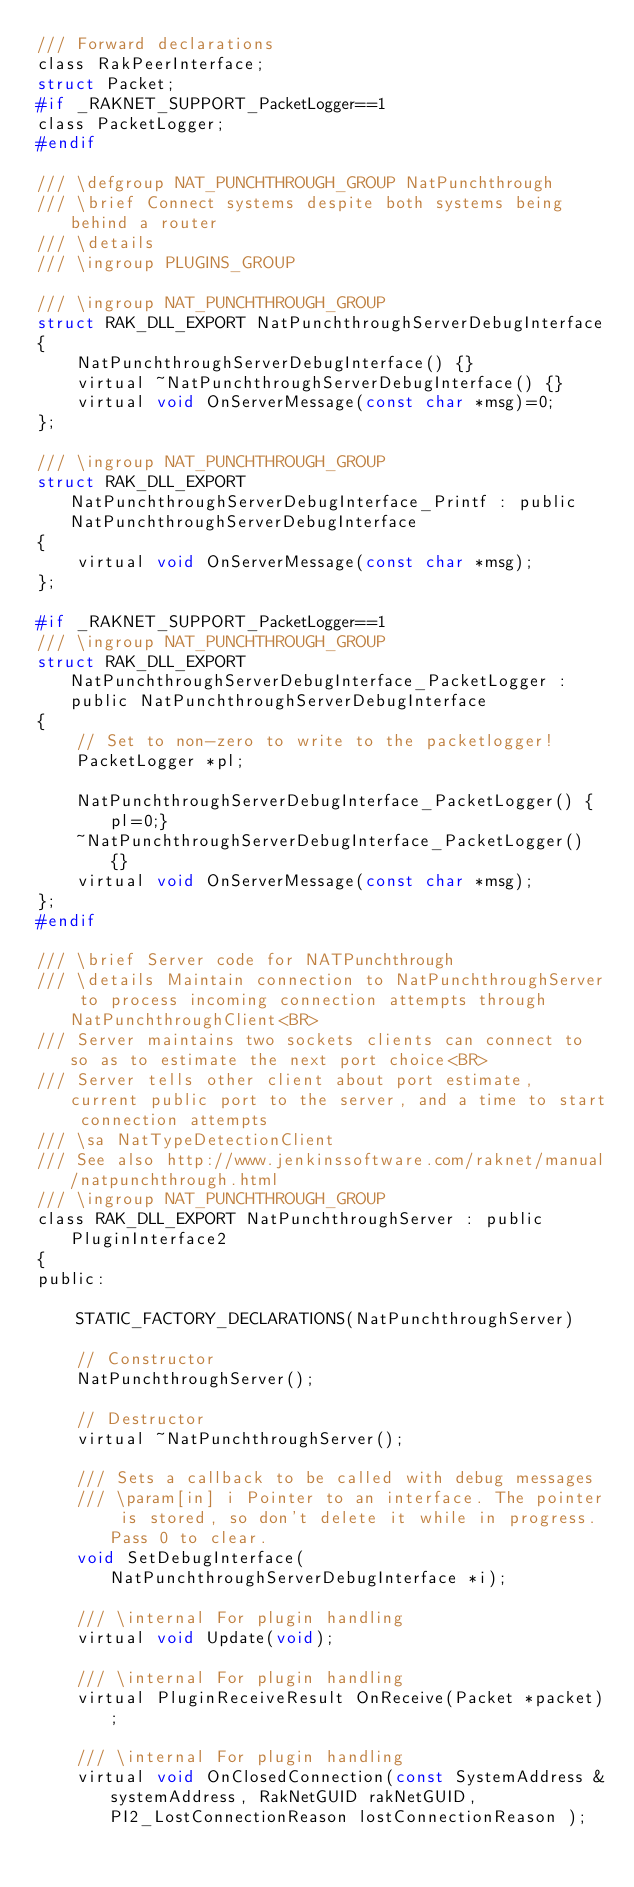Convert code to text. <code><loc_0><loc_0><loc_500><loc_500><_C_>/// Forward declarations
class RakPeerInterface;
struct Packet;
#if _RAKNET_SUPPORT_PacketLogger==1
class PacketLogger;
#endif

/// \defgroup NAT_PUNCHTHROUGH_GROUP NatPunchthrough
/// \brief Connect systems despite both systems being behind a router
/// \details
/// \ingroup PLUGINS_GROUP

/// \ingroup NAT_PUNCHTHROUGH_GROUP
struct RAK_DLL_EXPORT NatPunchthroughServerDebugInterface
{
	NatPunchthroughServerDebugInterface() {}
	virtual ~NatPunchthroughServerDebugInterface() {}
	virtual void OnServerMessage(const char *msg)=0;
};

/// \ingroup NAT_PUNCHTHROUGH_GROUP
struct RAK_DLL_EXPORT NatPunchthroughServerDebugInterface_Printf : public NatPunchthroughServerDebugInterface
{
	virtual void OnServerMessage(const char *msg);
};

#if _RAKNET_SUPPORT_PacketLogger==1
/// \ingroup NAT_PUNCHTHROUGH_GROUP
struct RAK_DLL_EXPORT NatPunchthroughServerDebugInterface_PacketLogger : public NatPunchthroughServerDebugInterface
{
	// Set to non-zero to write to the packetlogger!
	PacketLogger *pl;

	NatPunchthroughServerDebugInterface_PacketLogger() {pl=0;}
	~NatPunchthroughServerDebugInterface_PacketLogger() {}
	virtual void OnServerMessage(const char *msg);
};
#endif

/// \brief Server code for NATPunchthrough
/// \details Maintain connection to NatPunchthroughServer to process incoming connection attempts through NatPunchthroughClient<BR>
/// Server maintains two sockets clients can connect to so as to estimate the next port choice<BR>
/// Server tells other client about port estimate, current public port to the server, and a time to start connection attempts
/// \sa NatTypeDetectionClient
/// See also http://www.jenkinssoftware.com/raknet/manual/natpunchthrough.html
/// \ingroup NAT_PUNCHTHROUGH_GROUP
class RAK_DLL_EXPORT NatPunchthroughServer : public PluginInterface2
{
public:

	STATIC_FACTORY_DECLARATIONS(NatPunchthroughServer)

	// Constructor
	NatPunchthroughServer();

	// Destructor
	virtual ~NatPunchthroughServer();

	/// Sets a callback to be called with debug messages
	/// \param[in] i Pointer to an interface. The pointer is stored, so don't delete it while in progress. Pass 0 to clear.
	void SetDebugInterface(NatPunchthroughServerDebugInterface *i);

	/// \internal For plugin handling
	virtual void Update(void);

	/// \internal For plugin handling
	virtual PluginReceiveResult OnReceive(Packet *packet);

	/// \internal For plugin handling
	virtual void OnClosedConnection(const SystemAddress &systemAddress, RakNetGUID rakNetGUID, PI2_LostConnectionReason lostConnectionReason );</code> 